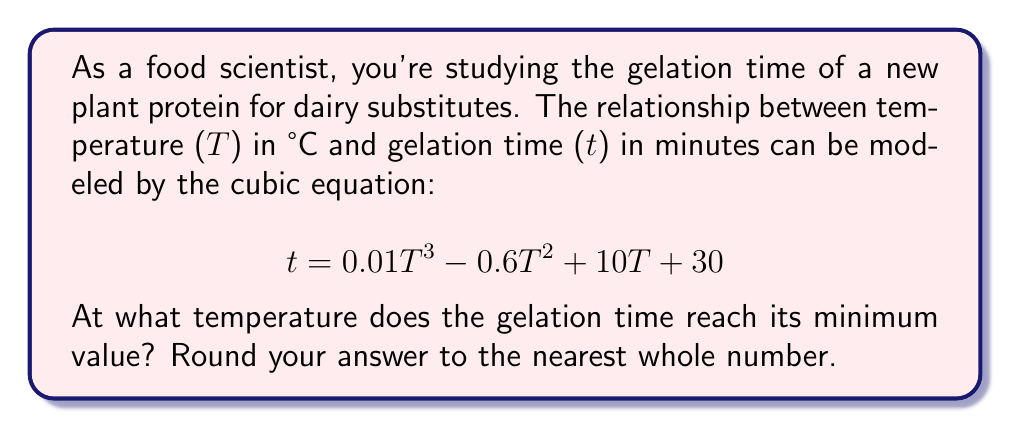Can you answer this question? To find the temperature at which the gelation time reaches its minimum value, we need to follow these steps:

1) First, we need to find the derivative of the gelation time function with respect to temperature:

   $$ \frac{dt}{dT} = 0.03T^2 - 1.2T + 10 $$

2) At the minimum point, the derivative will be equal to zero. So, we set the equation to zero:

   $$ 0.03T^2 - 1.2T + 10 = 0 $$

3) This is a quadratic equation. We can solve it using the quadratic formula:

   $$ T = \frac{-b \pm \sqrt{b^2 - 4ac}}{2a} $$

   Where $a = 0.03$, $b = -1.2$, and $c = 10$

4) Substituting these values:

   $$ T = \frac{1.2 \pm \sqrt{(-1.2)^2 - 4(0.03)(10)}}{2(0.03)} $$

5) Simplifying:

   $$ T = \frac{1.2 \pm \sqrt{1.44 - 1.2}}{0.06} = \frac{1.2 \pm \sqrt{0.24}}{0.06} = \frac{1.2 \pm 0.4899}{0.06} $$

6) This gives us two solutions:

   $$ T_1 = \frac{1.2 + 0.4899}{0.06} \approx 28.17 $$
   $$ T_2 = \frac{1.2 - 0.4899}{0.06} \approx 11.83 $$

7) To determine which of these is the minimum (rather than the maximum), we can check the second derivative:

   $$ \frac{d^2t}{dT^2} = 0.06T - 1.2 $$

   At $T = 28.17$, this is positive, indicating a minimum.

8) Rounding to the nearest whole number:

   $$ 28.17 \approx 28 $$

Therefore, the gelation time reaches its minimum value at approximately 28°C.
Answer: 28°C 